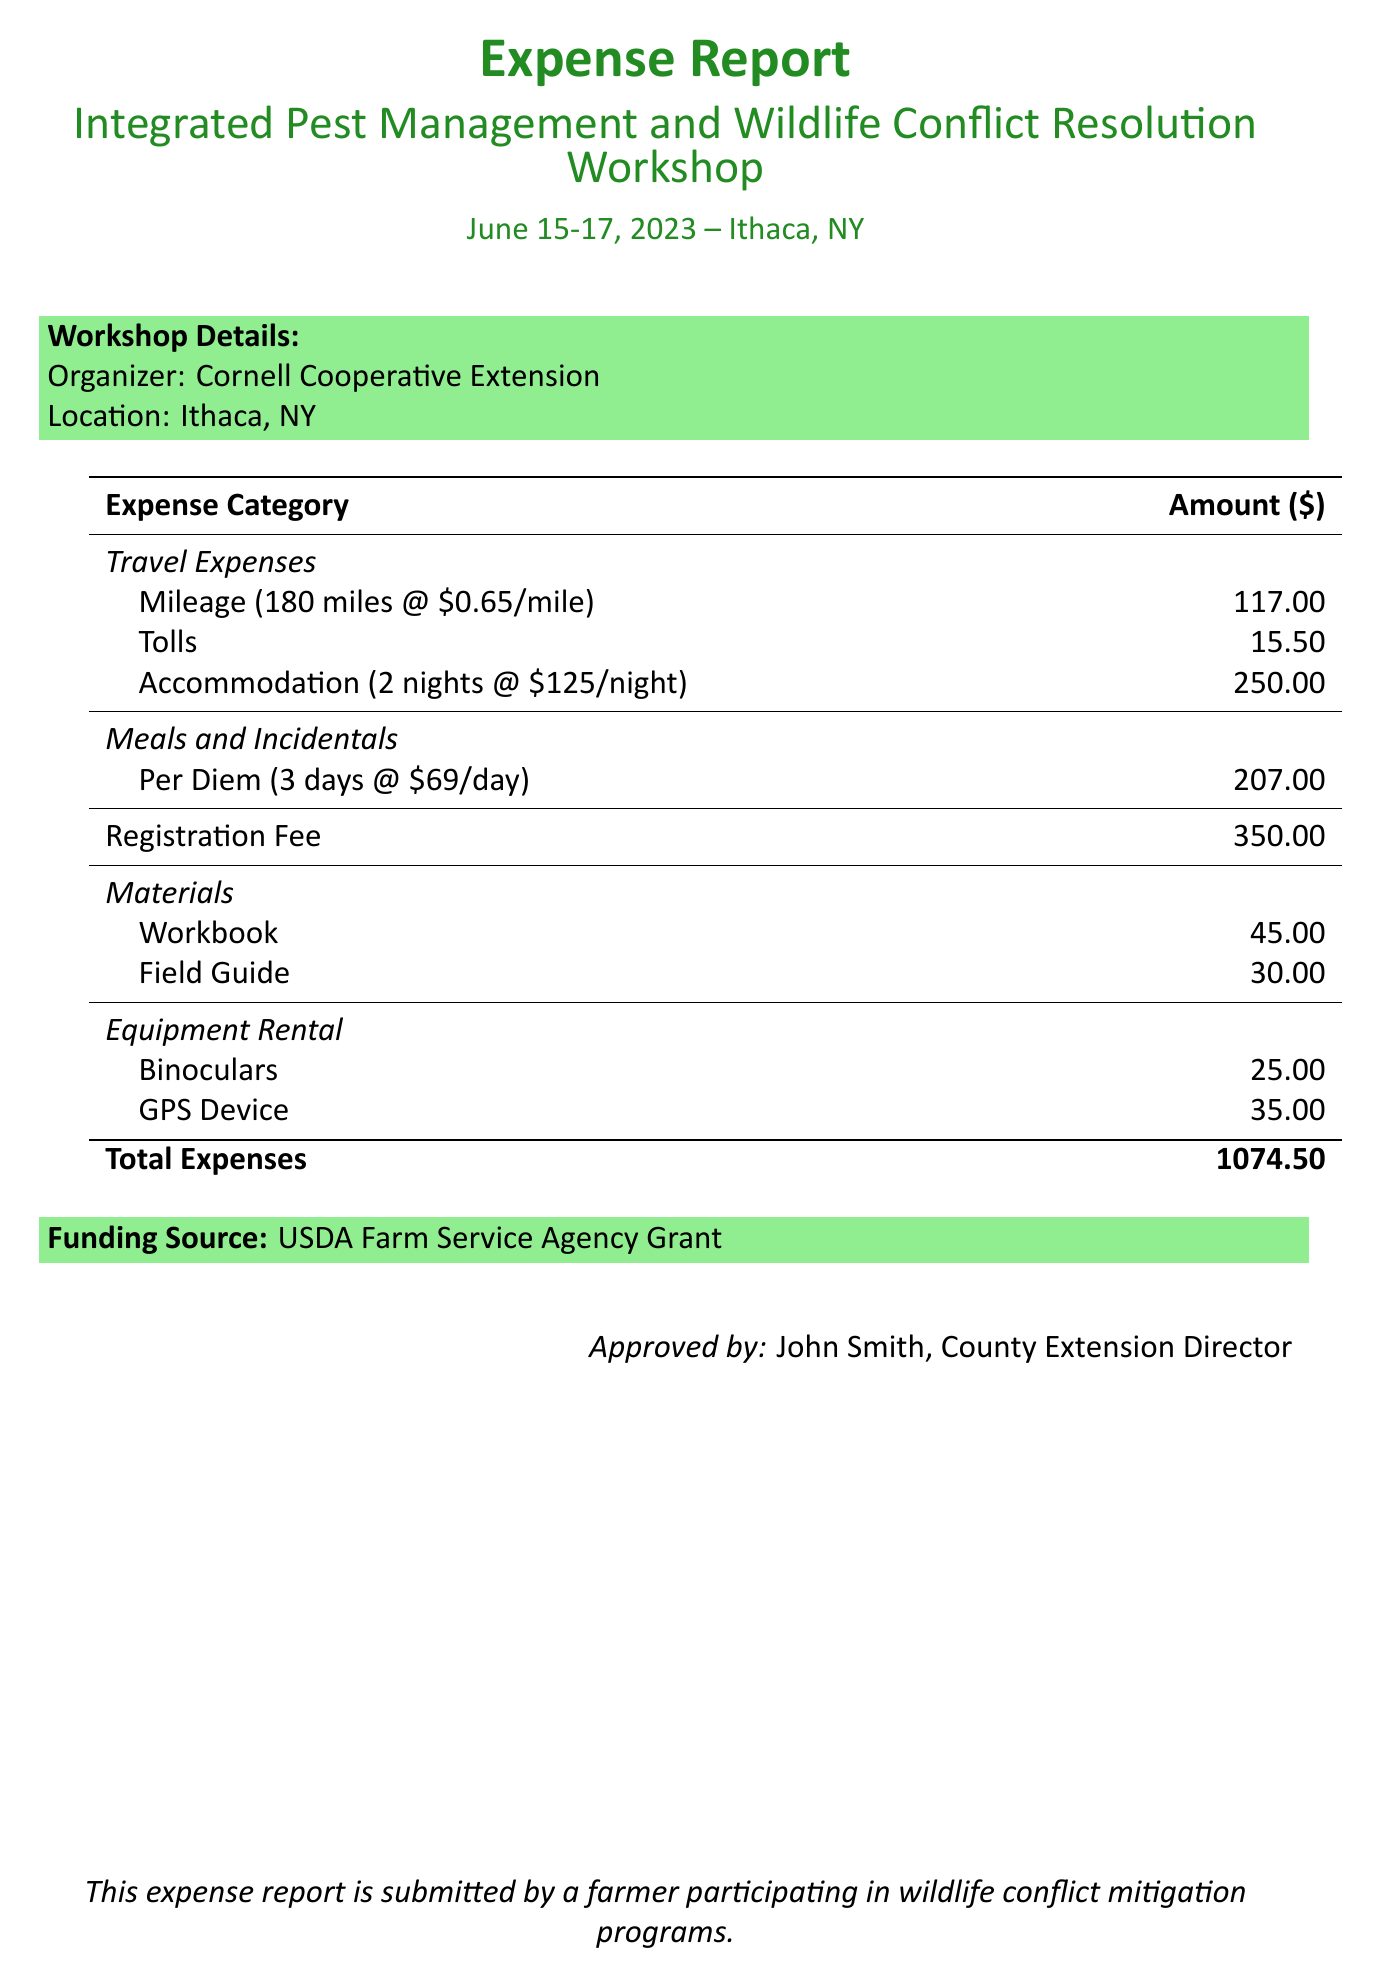What is the name of the workshop? The name of the workshop is detailed under workshopDetails, which specifies the workshop's title.
Answer: Integrated Pest Management and Wildlife Conflict Resolution Workshop What is the total expense amount? The total expense amount is listed at the bottom of the expense report, summarizing all costs incurred.
Answer: 1074.50 How many nights was accommodation booked? The number of nights stayed is mentioned in the accommodation section, providing specifics on lodging duration.
Answer: 2 Who organized the workshop? The organizer is identified in the workshopDetails section of the document, providing information about the entity responsible for the workshop.
Answer: Cornell Cooperative Extension What was the per diem rate? The per diem rate is outlined in the meals and incidentals section, reflecting daily meal allowances.
Answer: 69 How many days was the per diem calculated for? The document states the number of days the per diem covers, which is crucial for calculating total meal expenses.
Answer: 3 What is the funding source for the expenses? The funding source is specified in a dedicated section of the report, indicating where the financing for the expenses originated.
Answer: USDA Farm Service Agency Grant What was the registration fee for the workshop? The registration fee is clearly indicated in the expenses list, denoting an important cost associated with attending.
Answer: 350.00 What type of devices were rented for the workshop? The equipment rental section mentions specific items that were rented, highlighting additional costs associated with participation.
Answer: Binoculars, GPS Device 